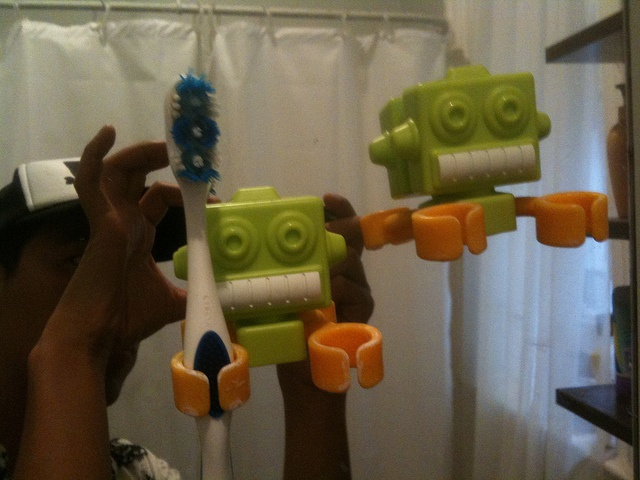Describe the objects in this image and their specific colors. I can see people in darkgray, black, maroon, tan, and gray tones and toothbrush in darkgray, black, tan, and gray tones in this image. 